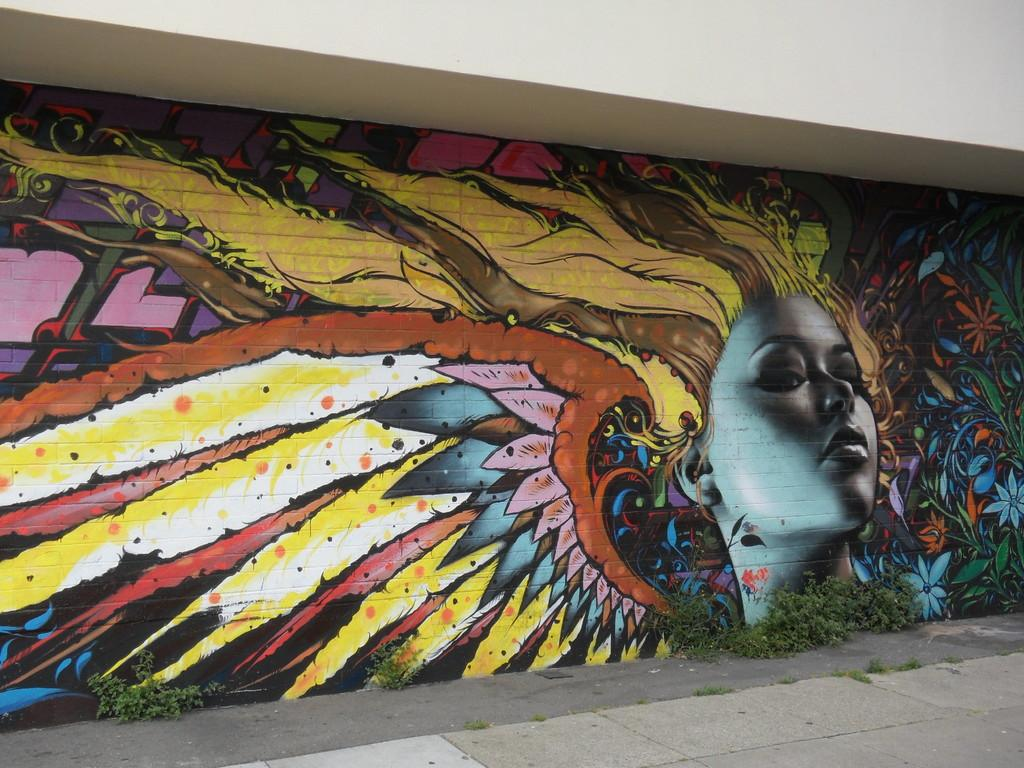What is present on the wall in the image? There is a painting of a woman on the wall. Can you describe the painting in more detail? Unfortunately, the provided facts do not give any additional details about the painting. What is the primary color used in the painting? The primary color used in the painting cannot be determined from the provided facts. How many frogs are sitting on the steel stitch in the image? There are no frogs or steel stitches present in the image. 